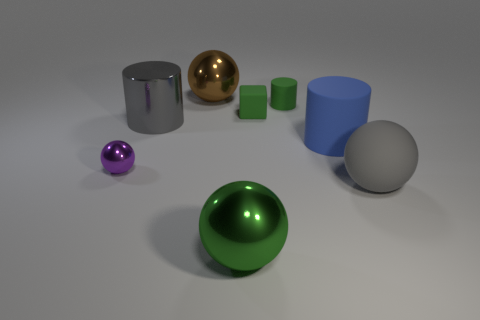Subtract all large green metallic spheres. How many spheres are left? 3 Add 1 gray metallic things. How many objects exist? 9 Subtract all brown balls. How many balls are left? 3 Add 2 big yellow metal objects. How many big yellow metal objects exist? 2 Subtract 1 gray cylinders. How many objects are left? 7 Subtract all cubes. How many objects are left? 7 Subtract all blue spheres. Subtract all yellow cubes. How many spheres are left? 4 Subtract all big gray shiny things. Subtract all large green balls. How many objects are left? 6 Add 8 tiny cylinders. How many tiny cylinders are left? 9 